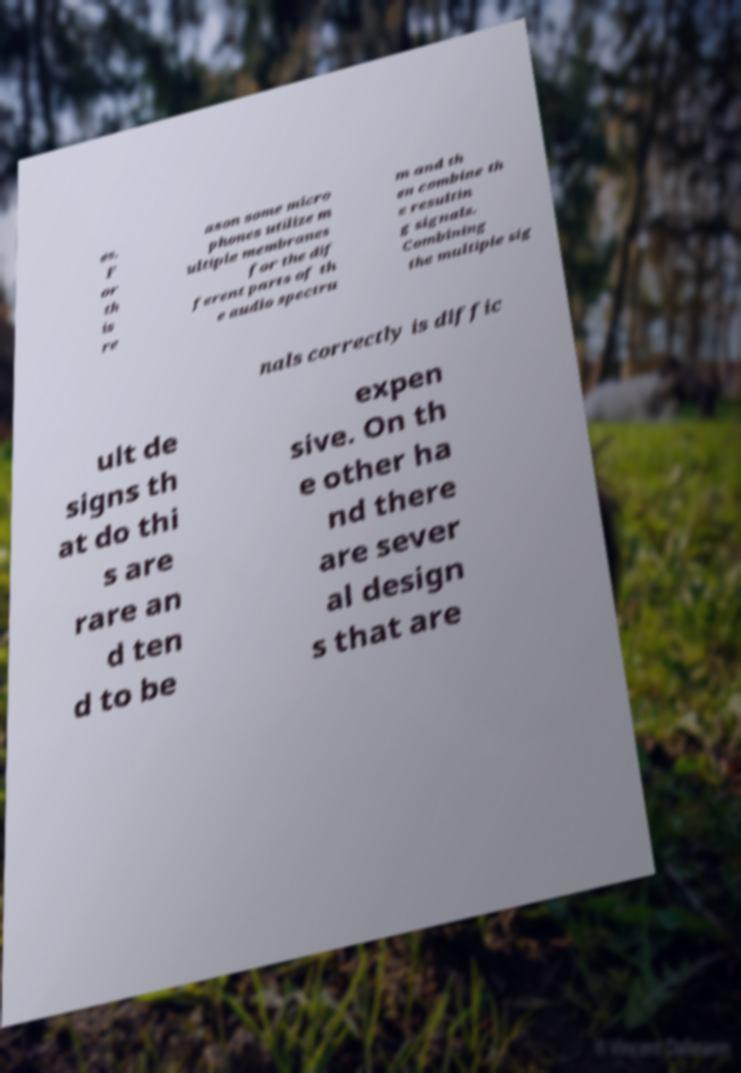Please read and relay the text visible in this image. What does it say? es. F or th is re ason some micro phones utilize m ultiple membranes for the dif ferent parts of th e audio spectru m and th en combine th e resultin g signals. Combining the multiple sig nals correctly is diffic ult de signs th at do thi s are rare an d ten d to be expen sive. On th e other ha nd there are sever al design s that are 